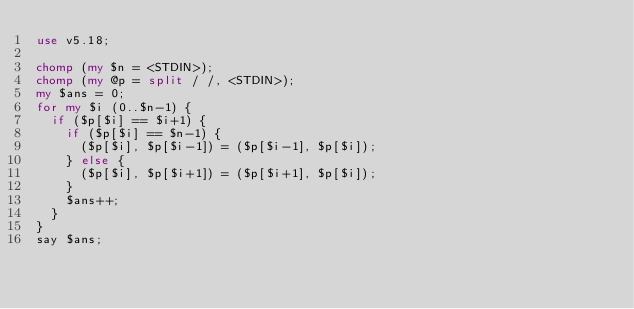Convert code to text. <code><loc_0><loc_0><loc_500><loc_500><_Perl_>use v5.18;

chomp (my $n = <STDIN>);
chomp (my @p = split / /, <STDIN>);
my $ans = 0;
for my $i (0..$n-1) {
  if ($p[$i] == $i+1) {
    if ($p[$i] == $n-1) {
      ($p[$i], $p[$i-1]) = ($p[$i-1], $p[$i]);
    } else {
      ($p[$i], $p[$i+1]) = ($p[$i+1], $p[$i]);
    }
    $ans++;
  }
}
say $ans;</code> 